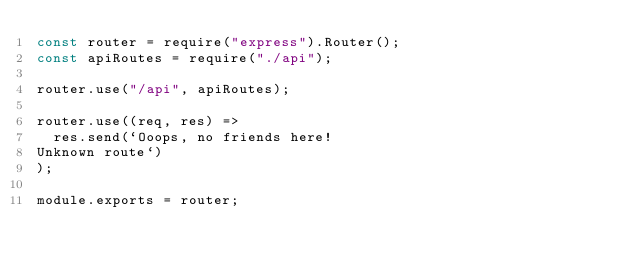<code> <loc_0><loc_0><loc_500><loc_500><_JavaScript_>const router = require("express").Router();
const apiRoutes = require("./api");

router.use("/api", apiRoutes);

router.use((req, res) =>
  res.send(`Ooops, no friends here!
Unknown route`)
);

module.exports = router;
</code> 